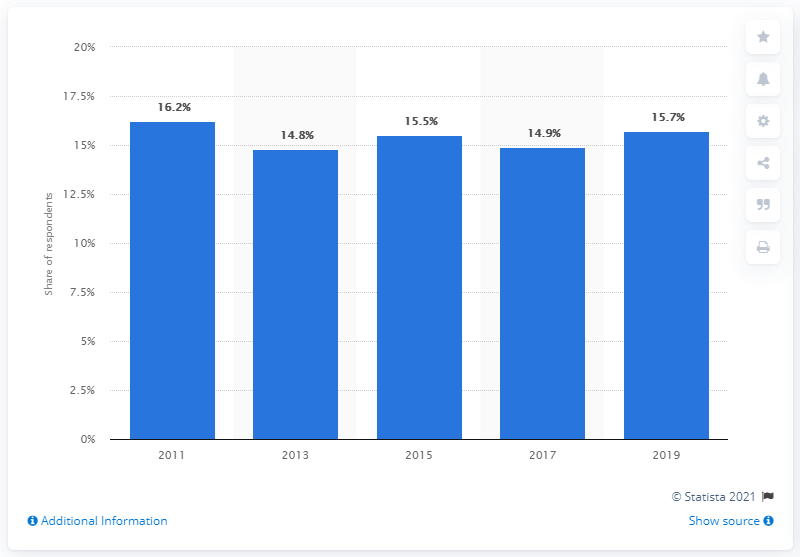Highlight a few significant elements in this photo. Since 2011, the victimization rate of cyber bullying has remained stable. 